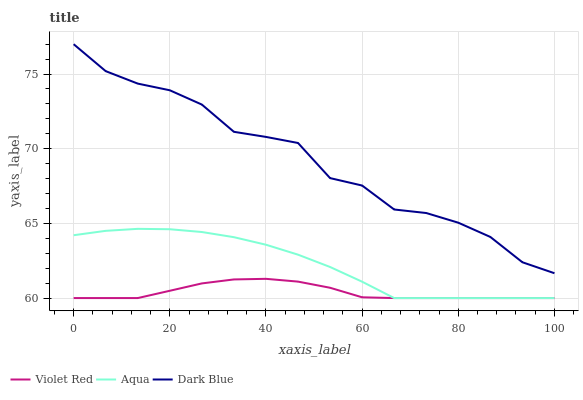Does Aqua have the minimum area under the curve?
Answer yes or no. No. Does Aqua have the maximum area under the curve?
Answer yes or no. No. Is Aqua the smoothest?
Answer yes or no. No. Is Aqua the roughest?
Answer yes or no. No. Does Aqua have the highest value?
Answer yes or no. No. Is Aqua less than Dark Blue?
Answer yes or no. Yes. Is Dark Blue greater than Violet Red?
Answer yes or no. Yes. Does Aqua intersect Dark Blue?
Answer yes or no. No. 